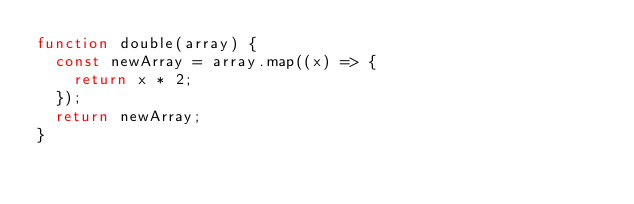Convert code to text. <code><loc_0><loc_0><loc_500><loc_500><_JavaScript_>function double(array) {
  const newArray = array.map((x) => { 
    return x * 2;
  });
  return newArray;
}</code> 